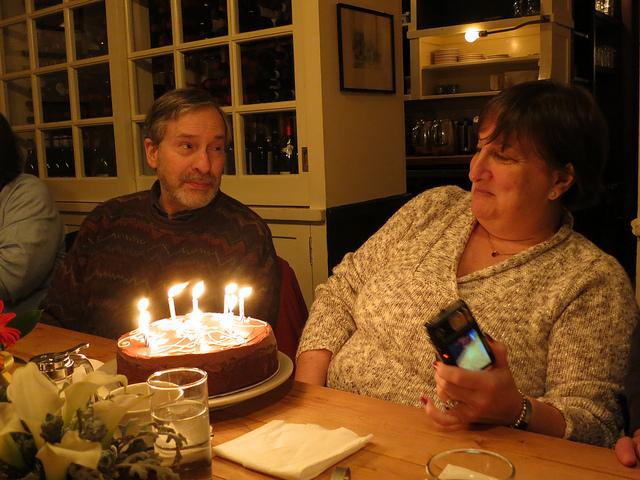What is the woman holding in her hand?
Give a very brief answer. Camera. How many candles are on the cake?
Answer briefly. 8. Is the woman wearing a watch?
Quick response, please. Yes. Does the man have a vision problem?
Short answer required. No. 